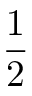Convert formula to latex. <formula><loc_0><loc_0><loc_500><loc_500>\frac { 1 } { 2 }</formula> 